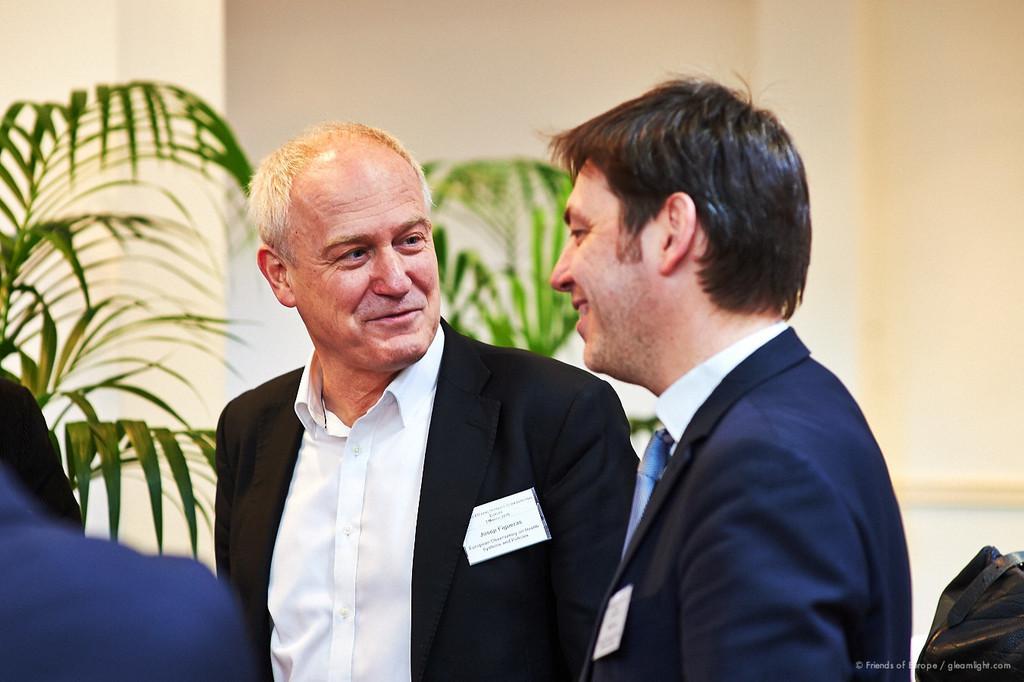How would you summarize this image in a sentence or two? In this image I can see in the middle two men are standing and also they are laughing, they are wearing the coats, shirts. In the background there are plants, at the top there is the wall. In the right hand side bottom there is the watermark. 